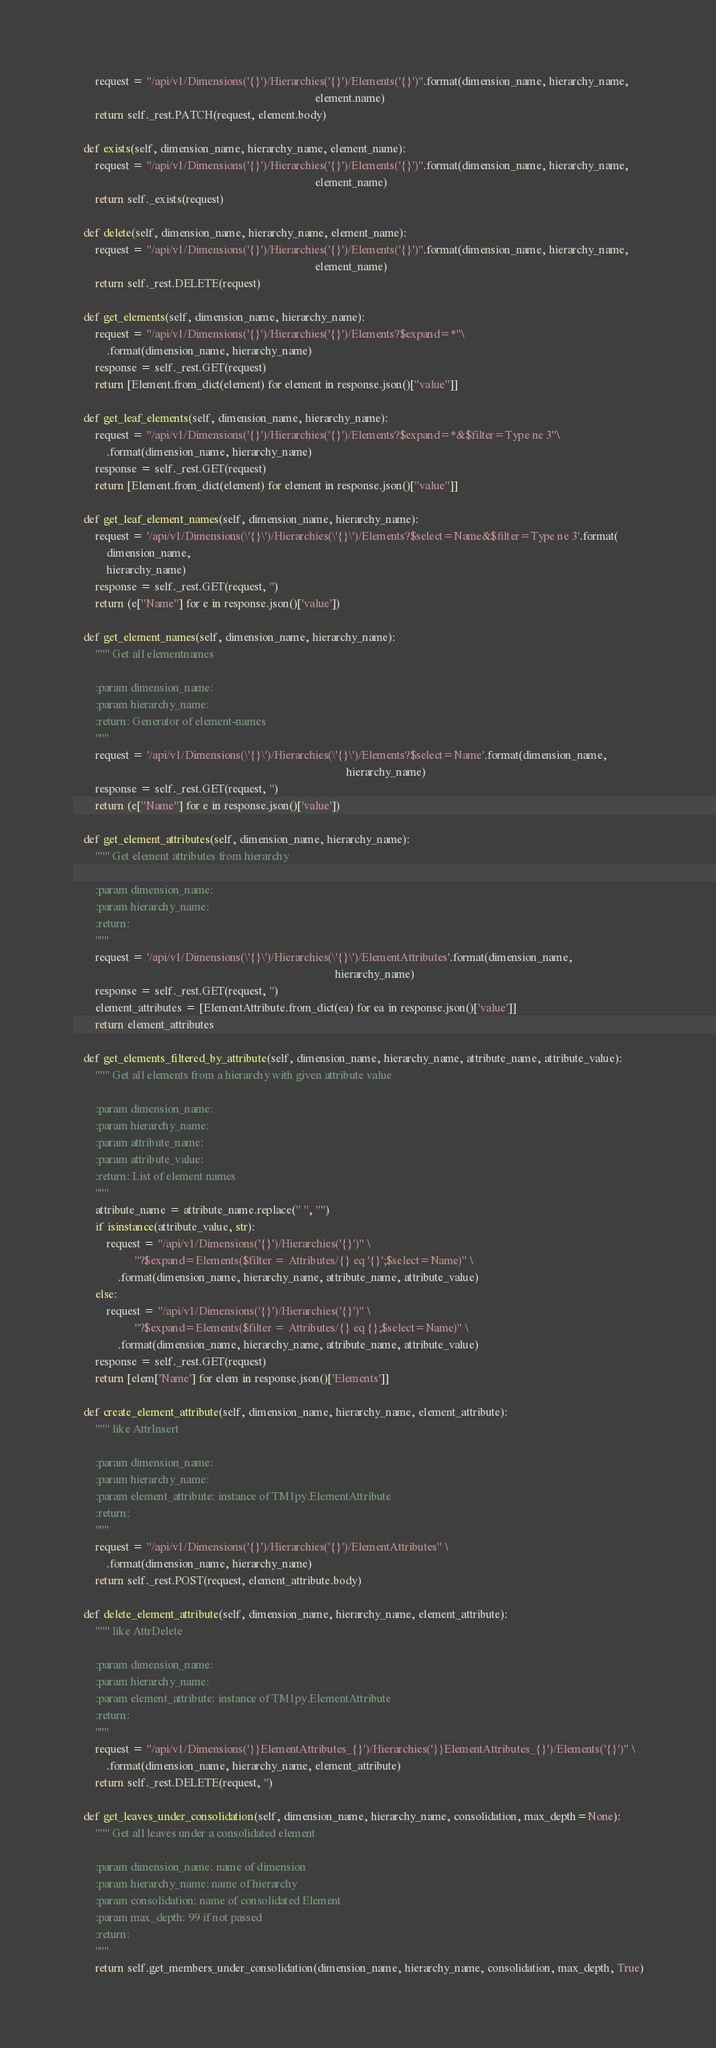Convert code to text. <code><loc_0><loc_0><loc_500><loc_500><_Python_>        request = "/api/v1/Dimensions('{}')/Hierarchies('{}')/Elements('{}')".format(dimension_name, hierarchy_name,
                                                                                     element.name)
        return self._rest.PATCH(request, element.body)

    def exists(self, dimension_name, hierarchy_name, element_name):
        request = "/api/v1/Dimensions('{}')/Hierarchies('{}')/Elements('{}')".format(dimension_name, hierarchy_name,
                                                                                     element_name)
        return self._exists(request)

    def delete(self, dimension_name, hierarchy_name, element_name):
        request = "/api/v1/Dimensions('{}')/Hierarchies('{}')/Elements('{}')".format(dimension_name, hierarchy_name,
                                                                                     element_name)
        return self._rest.DELETE(request)

    def get_elements(self, dimension_name, hierarchy_name):
        request = "/api/v1/Dimensions('{}')/Hierarchies('{}')/Elements?$expand=*"\
            .format(dimension_name, hierarchy_name)
        response = self._rest.GET(request)
        return [Element.from_dict(element) for element in response.json()["value"]]

    def get_leaf_elements(self, dimension_name, hierarchy_name):
        request = "/api/v1/Dimensions('{}')/Hierarchies('{}')/Elements?$expand=*&$filter=Type ne 3"\
            .format(dimension_name, hierarchy_name)
        response = self._rest.GET(request)
        return [Element.from_dict(element) for element in response.json()["value"]]

    def get_leaf_element_names(self, dimension_name, hierarchy_name):
        request = '/api/v1/Dimensions(\'{}\')/Hierarchies(\'{}\')/Elements?$select=Name&$filter=Type ne 3'.format(
            dimension_name,
            hierarchy_name)
        response = self._rest.GET(request, '')
        return (e["Name"] for e in response.json()['value'])

    def get_element_names(self, dimension_name, hierarchy_name):
        """ Get all elementnames
        
        :param dimension_name: 
        :param hierarchy_name: 
        :return: Generator of element-names
        """
        request = '/api/v1/Dimensions(\'{}\')/Hierarchies(\'{}\')/Elements?$select=Name'.format(dimension_name,
                                                                                                hierarchy_name)
        response = self._rest.GET(request, '')
        return (e["Name"] for e in response.json()['value'])

    def get_element_attributes(self, dimension_name, hierarchy_name):
        """ Get element attributes from hierarchy
    
        :param dimension_name:
        :param hierarchy_name:
        :return:
        """
        request = '/api/v1/Dimensions(\'{}\')/Hierarchies(\'{}\')/ElementAttributes'.format(dimension_name,
                                                                                            hierarchy_name)
        response = self._rest.GET(request, '')
        element_attributes = [ElementAttribute.from_dict(ea) for ea in response.json()['value']]
        return element_attributes

    def get_elements_filtered_by_attribute(self, dimension_name, hierarchy_name, attribute_name, attribute_value):
        """ Get all elements from a hierarchy with given attribute value
    
        :param dimension_name:
        :param hierarchy_name:
        :param attribute_name:
        :param attribute_value:
        :return: List of element names
        """
        attribute_name = attribute_name.replace(" ", "")
        if isinstance(attribute_value, str):
            request = "/api/v1/Dimensions('{}')/Hierarchies('{}')" \
                      "?$expand=Elements($filter = Attributes/{} eq '{}';$select=Name)" \
                .format(dimension_name, hierarchy_name, attribute_name, attribute_value)
        else:
            request = "/api/v1/Dimensions('{}')/Hierarchies('{}')" \
                      "?$expand=Elements($filter = Attributes/{} eq {};$select=Name)" \
                .format(dimension_name, hierarchy_name, attribute_name, attribute_value)
        response = self._rest.GET(request)
        return [elem['Name'] for elem in response.json()['Elements']]

    def create_element_attribute(self, dimension_name, hierarchy_name, element_attribute):
        """ like AttrInsert

        :param dimension_name:
        :param hierarchy_name:
        :param element_attribute: instance of TM1py.ElementAttribute
        :return:
        """
        request = "/api/v1/Dimensions('{}')/Hierarchies('{}')/ElementAttributes" \
            .format(dimension_name, hierarchy_name)
        return self._rest.POST(request, element_attribute.body)

    def delete_element_attribute(self, dimension_name, hierarchy_name, element_attribute):
        """ like AttrDelete

        :param dimension_name:
        :param hierarchy_name:
        :param element_attribute: instance of TM1py.ElementAttribute
        :return:
        """
        request = "/api/v1/Dimensions('}}ElementAttributes_{}')/Hierarchies('}}ElementAttributes_{}')/Elements('{}')" \
            .format(dimension_name, hierarchy_name, element_attribute)
        return self._rest.DELETE(request, '')

    def get_leaves_under_consolidation(self, dimension_name, hierarchy_name, consolidation, max_depth=None):
        """ Get all leaves under a consolidated element
        
        :param dimension_name: name of dimension
        :param hierarchy_name: name of hierarchy
        :param consolidation: name of consolidated Element
        :param max_depth: 99 if not passed
        :return: 
        """
        return self.get_members_under_consolidation(dimension_name, hierarchy_name, consolidation, max_depth, True)
</code> 